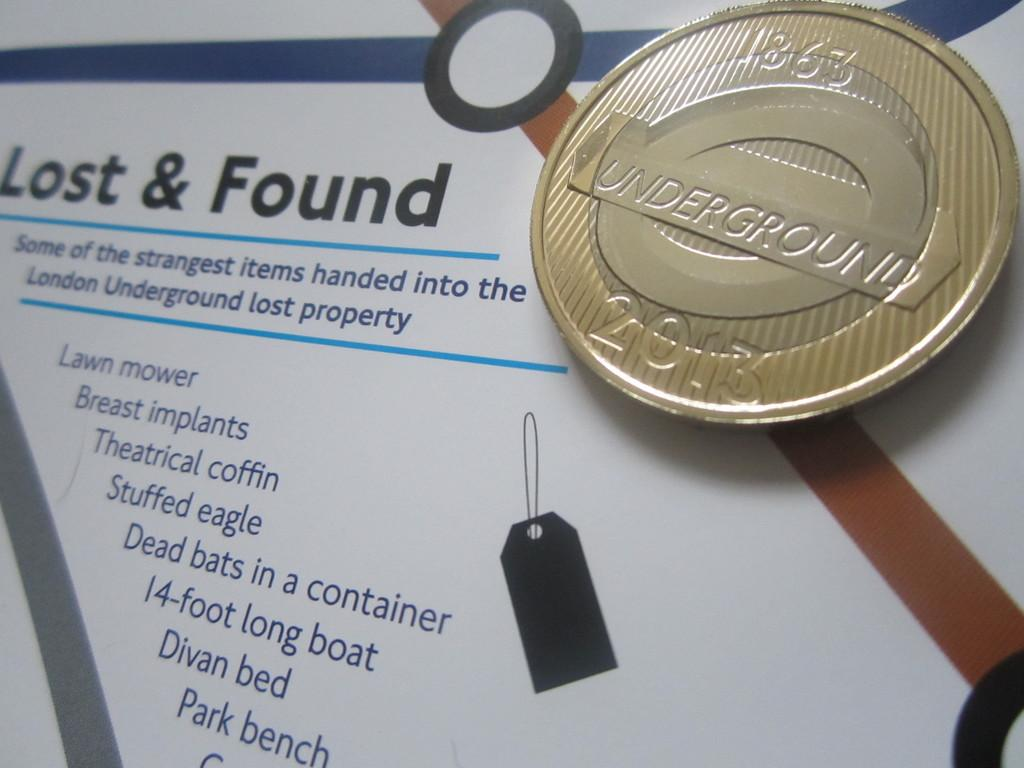<image>
Create a compact narrative representing the image presented. a billboard for the Lost & Found for the 2013 Underground 